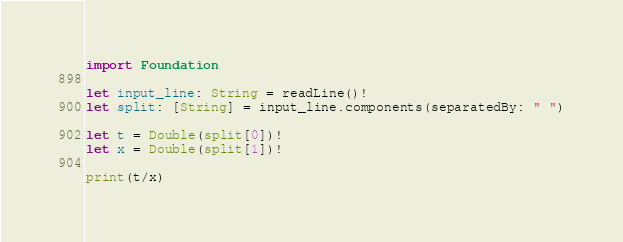<code> <loc_0><loc_0><loc_500><loc_500><_Swift_>import Foundation
 
let input_line: String = readLine()!
let split: [String] = input_line.components(separatedBy: " ")
 
let t = Double(split[0])!
let x = Double(split[1])!

print(t/x)</code> 